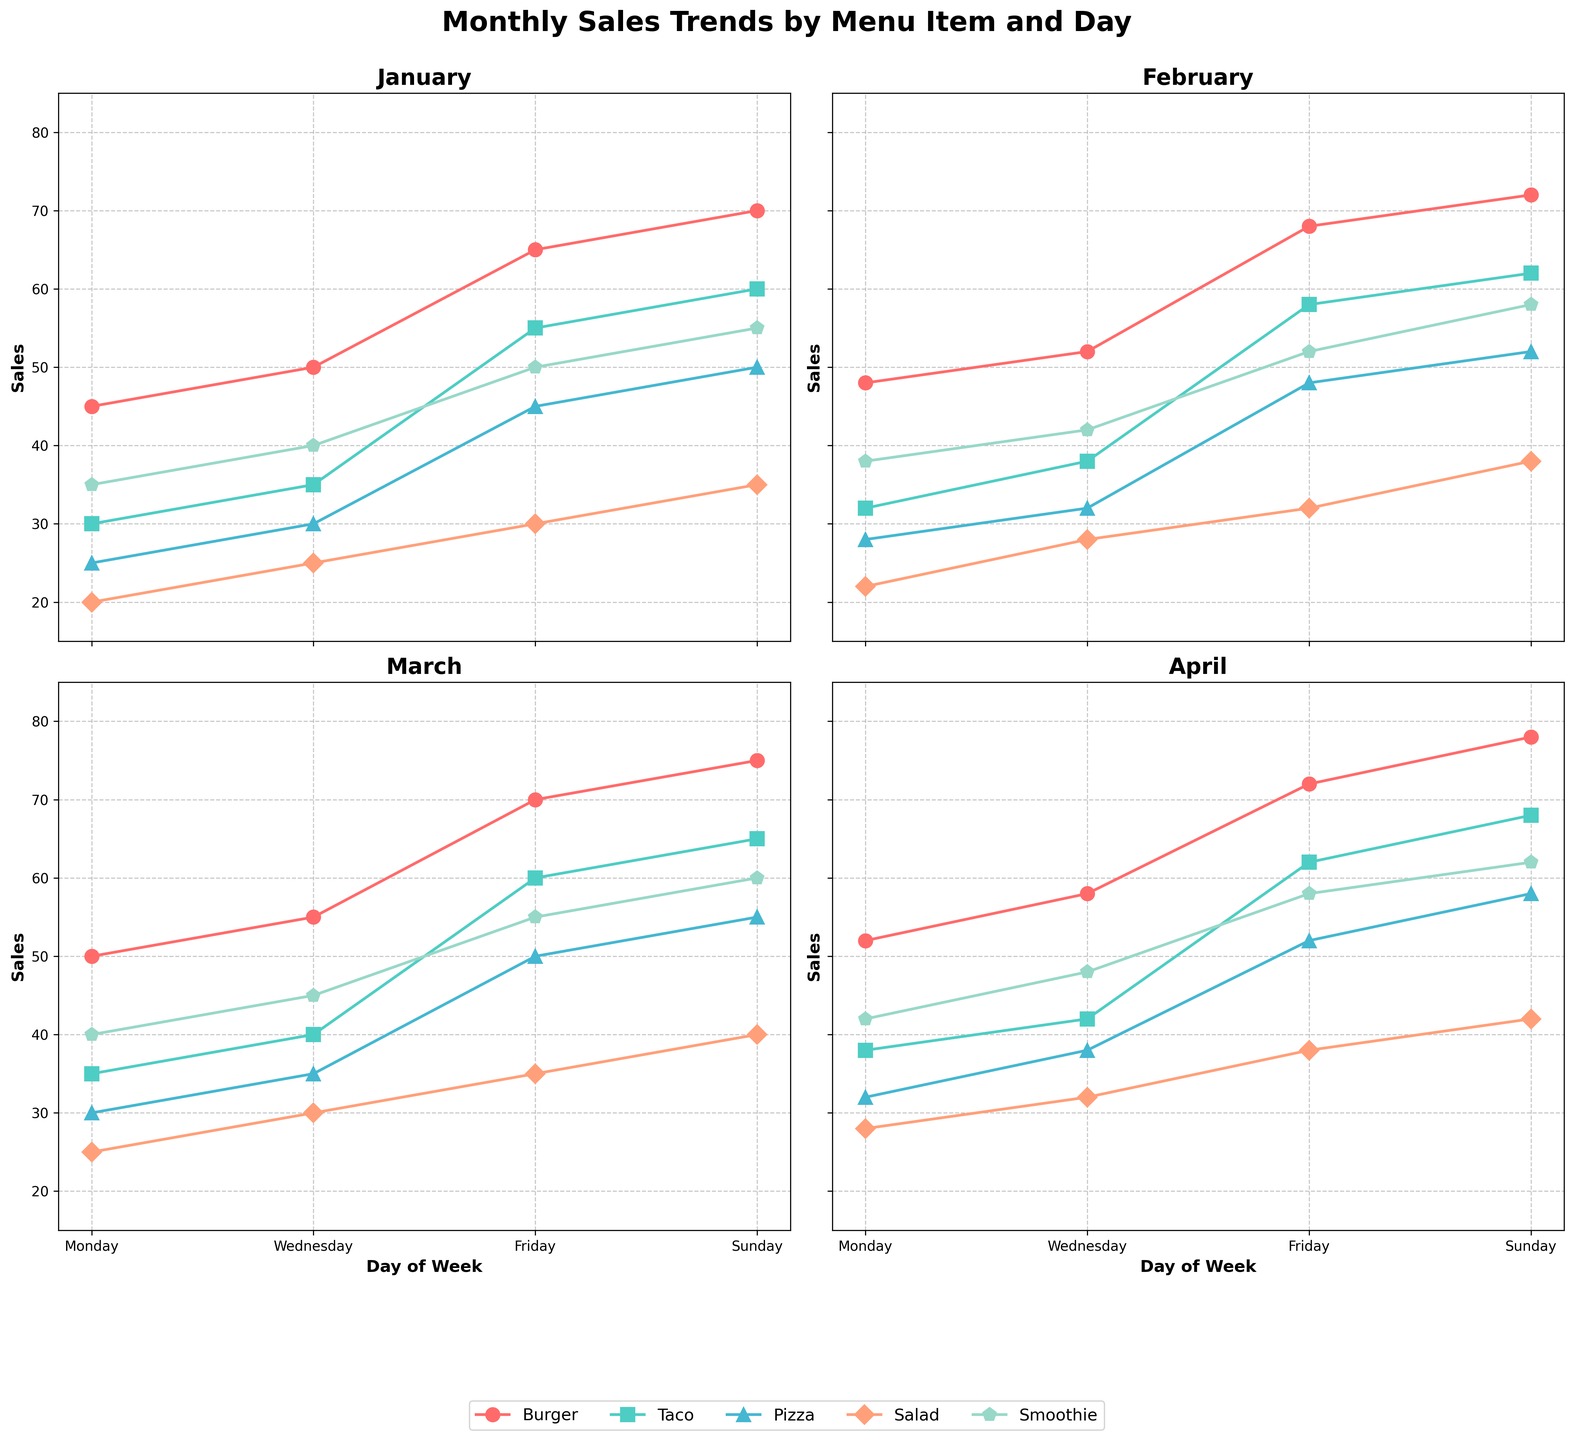What is the average sales of Smoothies on Fridays over the four months? To find the average sales of Smoothies on Fridays, we need to add the sales for each month and then divide by the number of months. The sales are: 50 (January), 52 (February), 55 (March), and 58 (April). Summing these values gives 215. Dividing by 4 yields an average of 53.75.
Answer: 53.75 Which menu item has the highest sales on Sundays in March? On Sundays in March, the sales for each item are as follows: Burger - 75, Taco - 65, Pizza - 55, Salad - 40, Smoothie - 60. The highest value among these is the sales of Burgers.
Answer: Burger How does the sale of Tacos on Wednesdays compare between January and April? The sales of Tacos on Wednesdays in January are 35, whereas in April they are 42. Comparing these values, April has higher sales.
Answer: April What is the total sale of Pizzas in February? To find the total sale of Pizzas in February, sum the sales on each day: 28 (Monday), 32 (Wednesday), 48 (Friday), and 52 (Sunday). Summing these values gives a total of 160.
Answer: 160 Which day of the week has the most consistent sales for Burgers? To determine consistency, we look at the sales variance across months for each day. For Burgers: Monday sales are 45, 48, 50, 52 with variance 5.5; Wednesday sales are 50, 52, 55, 58 with variance 10.67; Friday sales are 65, 68, 70, 72 with variance 8.67; Sunday sales are 70, 72, 75, 78 with variance 8.67. The smallest variance is for Mondays, showing the most consistency.
Answer: Monday What is the increase in sales of Smoothies from January to April on Sundays? To find the increase, subtract the sales in January from the sales in April on Sundays. The sales are 55 (January) and 62 (April). The increase is 62 - 55, which equals 7.
Answer: 7 On which day of the week do Tacos see the highest sales, and in which month? On each day of the week, we look at the maximum sales figures for Tacos: Monday - 38 (April), Wednesday - 42 (April), Friday - 62 (April), Sunday - 68 (April). The highest value is 68 on a Sunday in April.
Answer: Sunday, April If you were to stock up more on a specific menu item on Fridays, which one would it be based on these trends? On Fridays, the sales of each item reach the following values in April: Burger - 72, Taco - 62, Pizza - 52, Salad - 38, Smoothie - 58. The highest value is the sales of Burgers.
Answer: Burger 